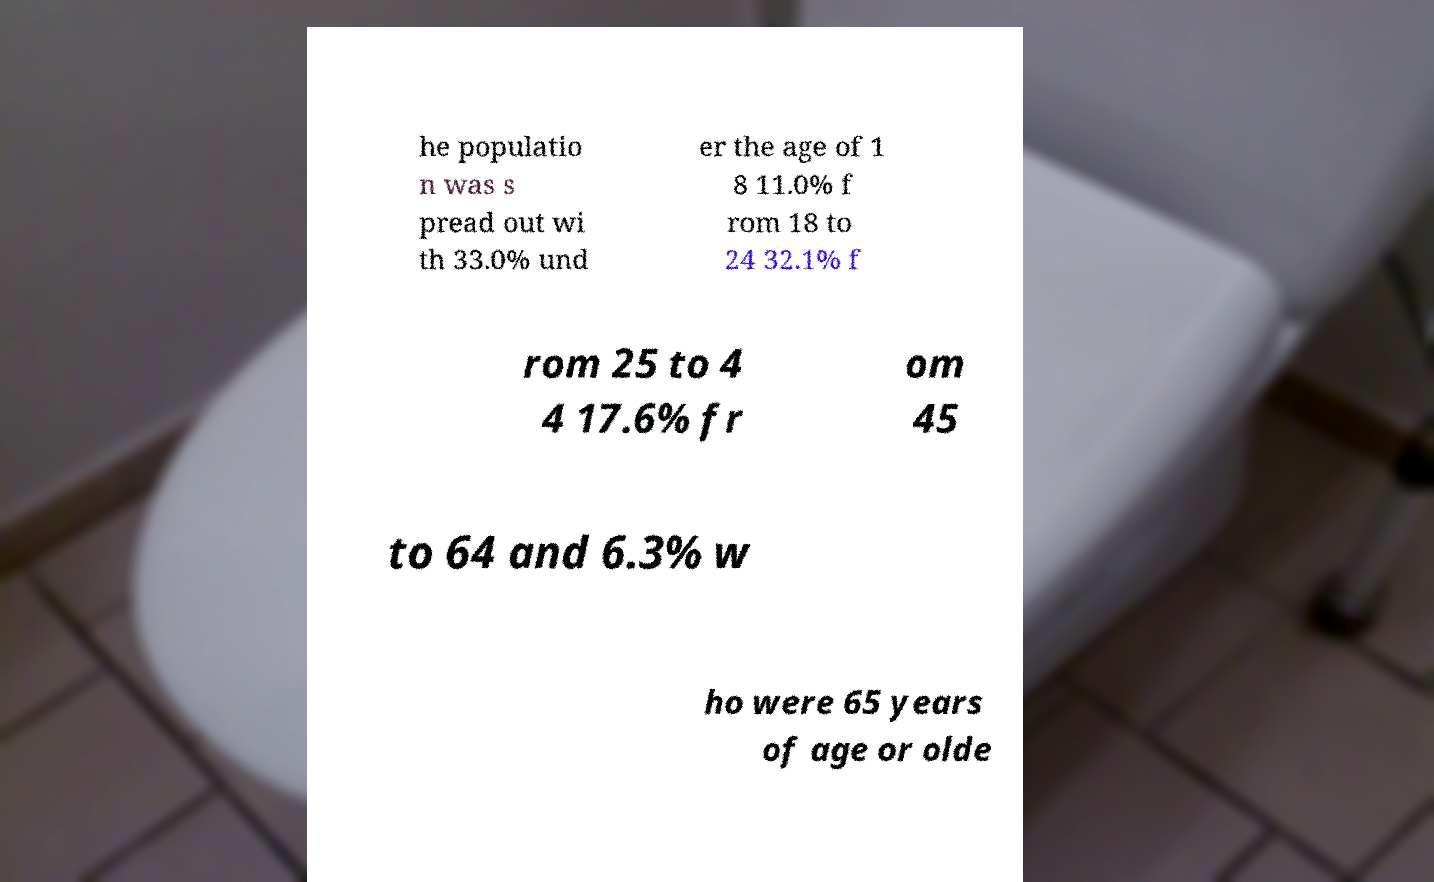Can you accurately transcribe the text from the provided image for me? he populatio n was s pread out wi th 33.0% und er the age of 1 8 11.0% f rom 18 to 24 32.1% f rom 25 to 4 4 17.6% fr om 45 to 64 and 6.3% w ho were 65 years of age or olde 